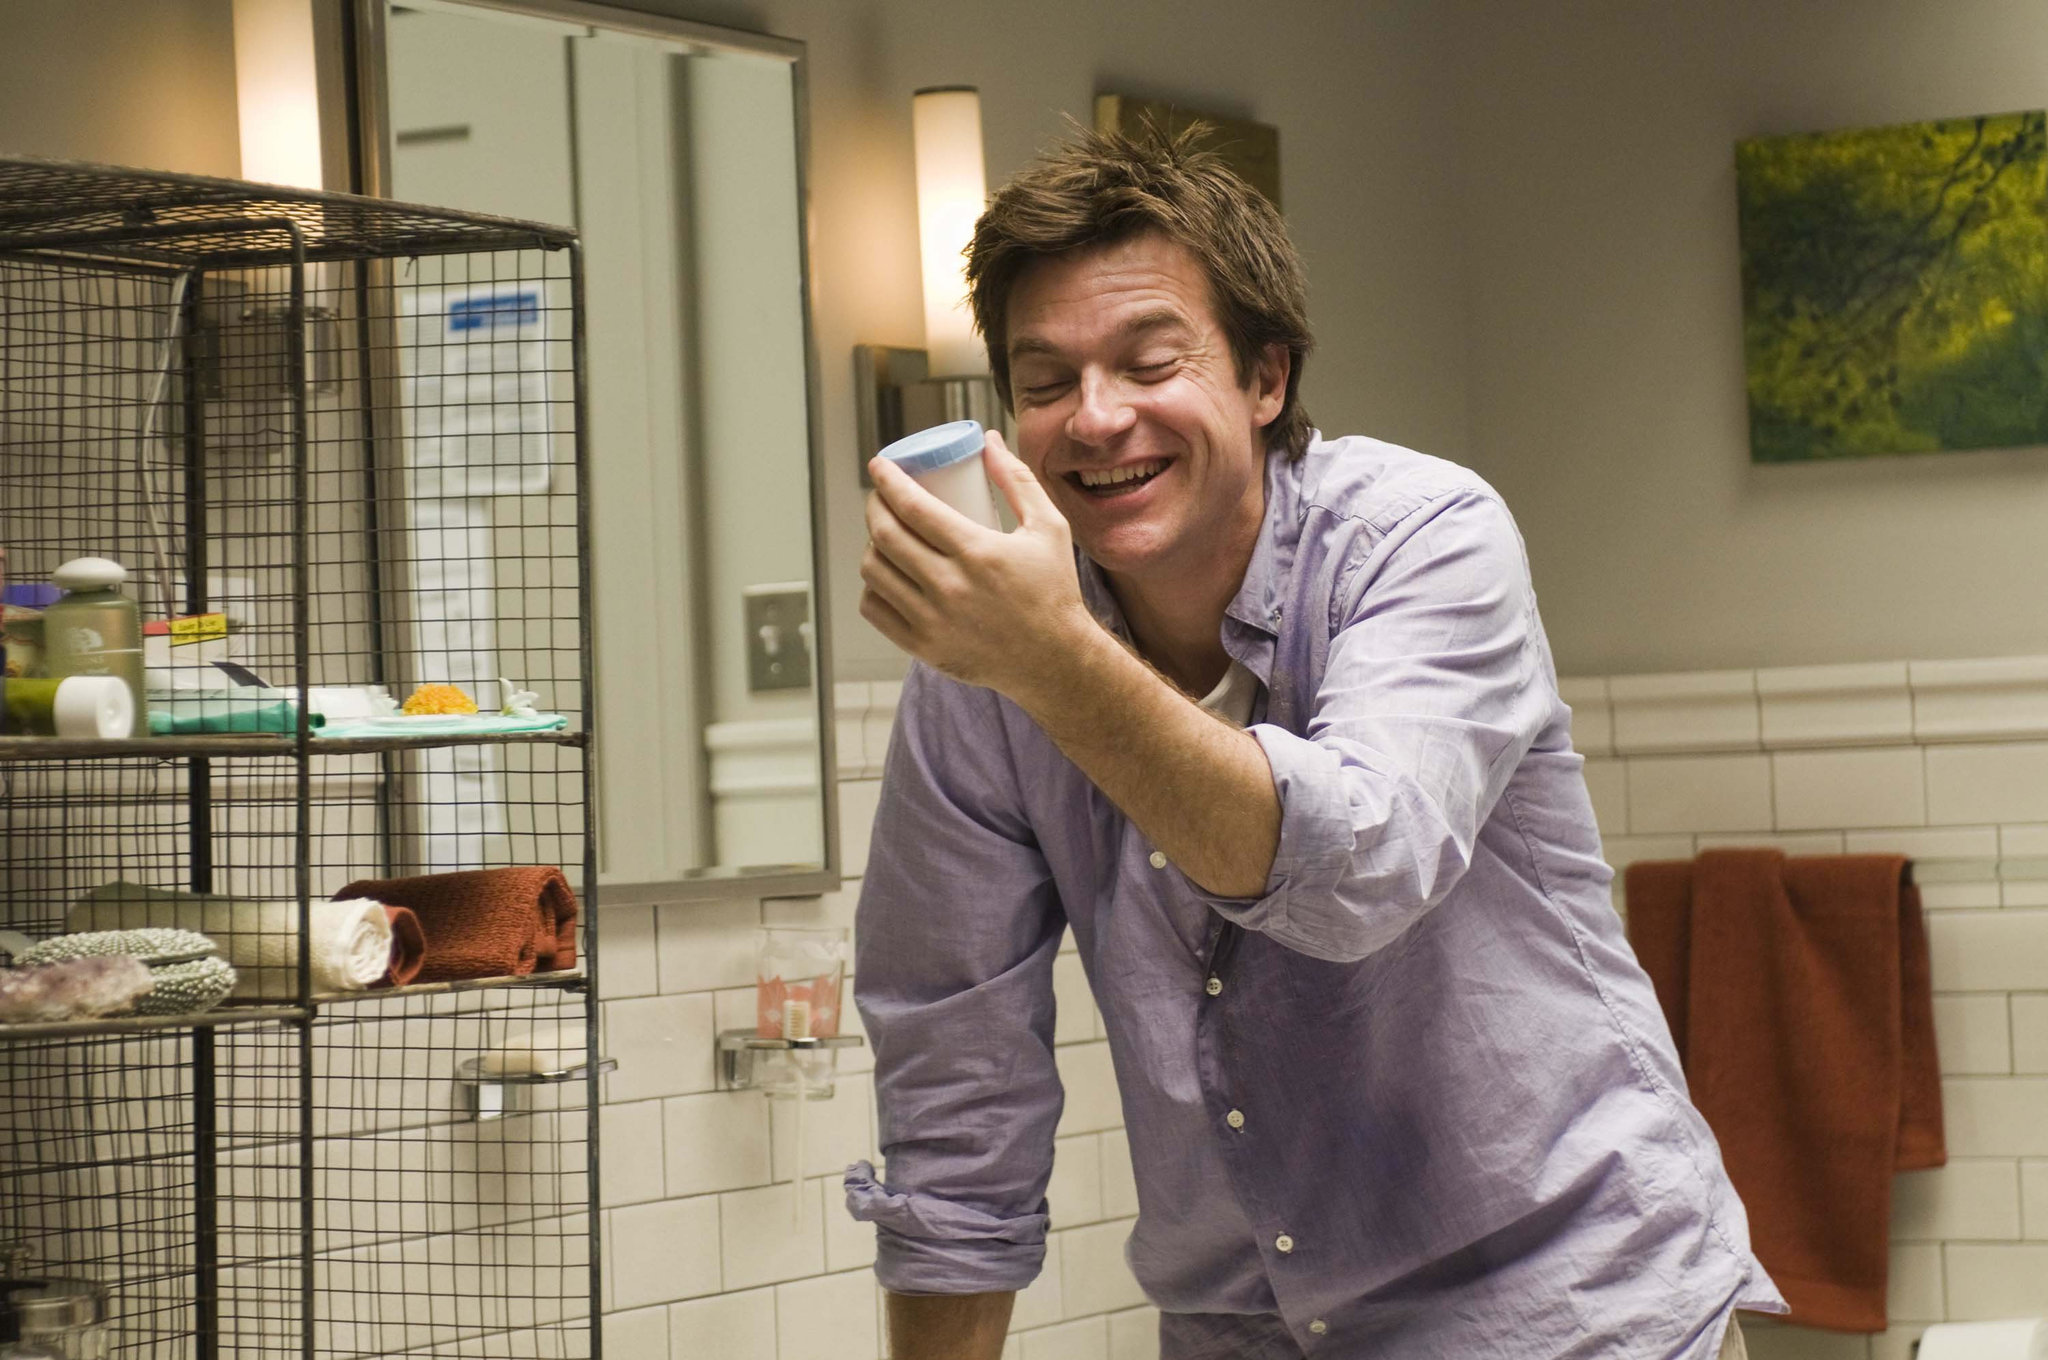How does the image capture the essence of joy and light-heartedness? The image captures the essence of joy and light-heartedness through several subtle yet powerful elements. The man's expression is the focal point, with his eyes closed and a broad smile that exudes genuine happiness. The way he holds the blue cup to his face adds to the candidness of the moment. His casually rolled-up sleeves and relaxed posture contribute to the overall sense of ease and spontaneity. The colorful elements like the purple shirt, the bright yellow bird, and the warm lighting further amplify the cheerful ambiance. Additionally, the unusual placement of the birdcage in the bathroom brings an unexpected and whimsical touch, enhancing the playful nature of the scene. 